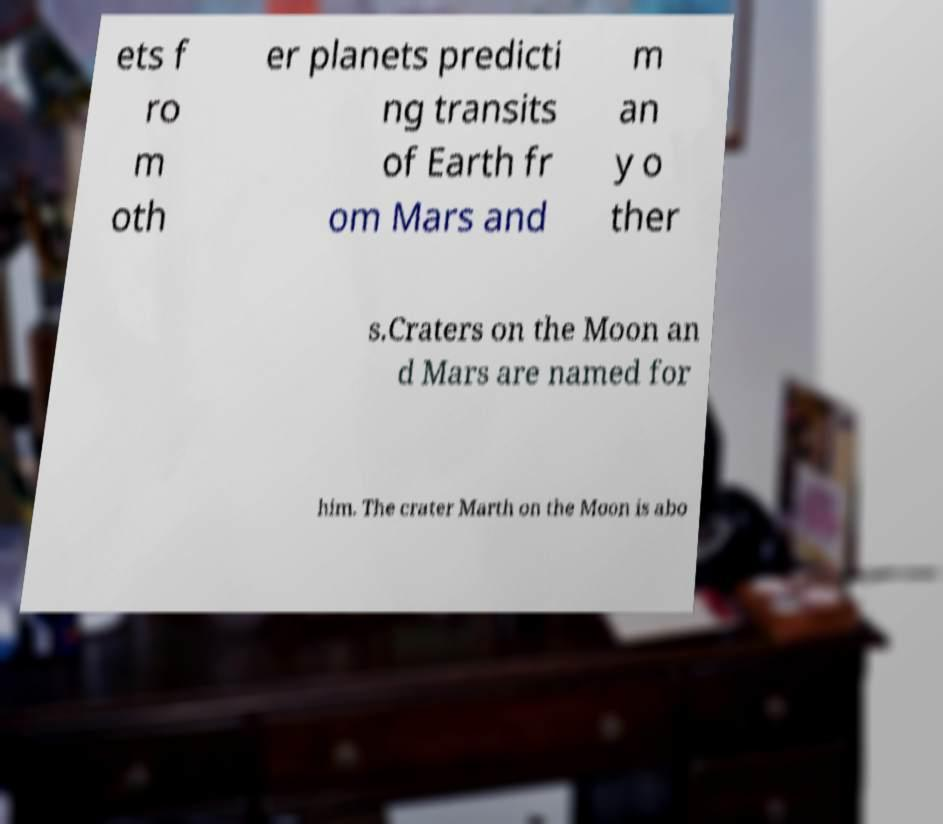For documentation purposes, I need the text within this image transcribed. Could you provide that? ets f ro m oth er planets predicti ng transits of Earth fr om Mars and m an y o ther s.Craters on the Moon an d Mars are named for him. The crater Marth on the Moon is abo 